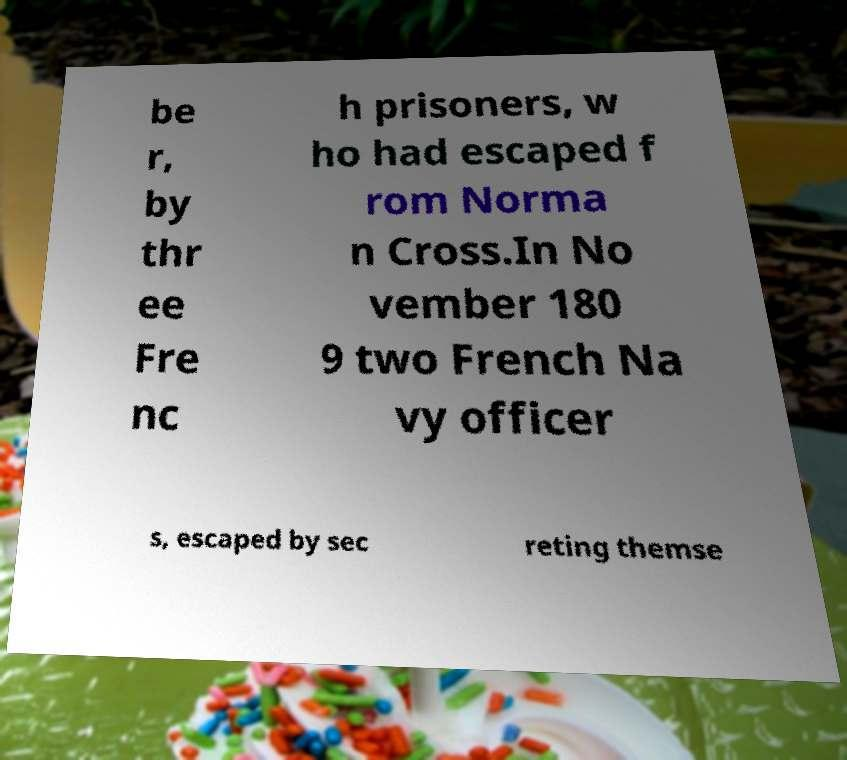Could you extract and type out the text from this image? be r, by thr ee Fre nc h prisoners, w ho had escaped f rom Norma n Cross.In No vember 180 9 two French Na vy officer s, escaped by sec reting themse 